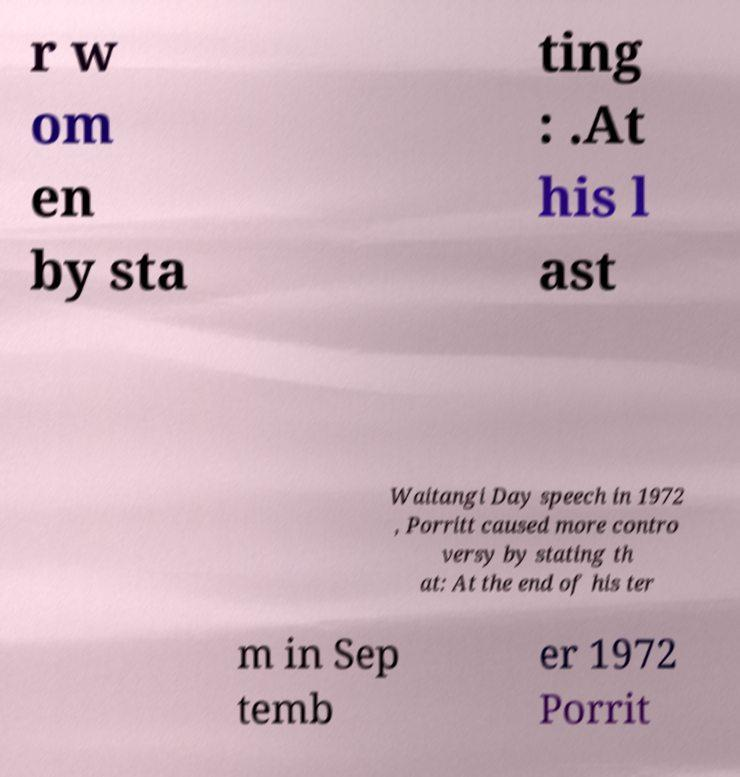Could you assist in decoding the text presented in this image and type it out clearly? r w om en by sta ting : .At his l ast Waitangi Day speech in 1972 , Porritt caused more contro versy by stating th at: At the end of his ter m in Sep temb er 1972 Porrit 